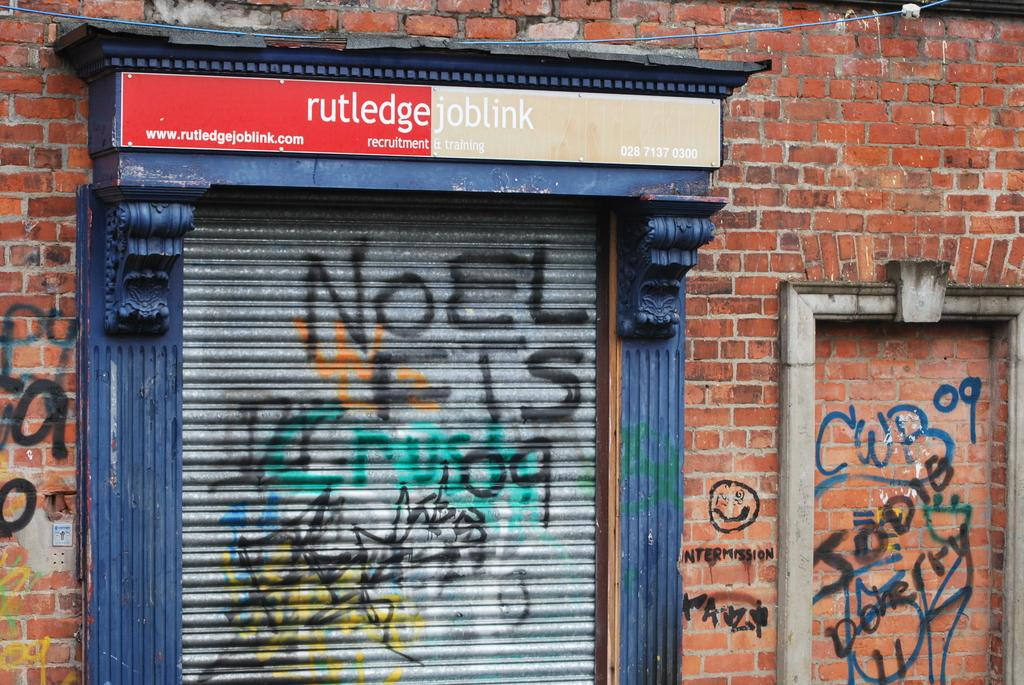What is the main object in the image? There is a board in the image. What can be seen on the shutter in the image? There are scribblings on the shutter in the image. What else in the image has scribblings on it? There are scribblings on the wall in the image. Where is the throne located in the image? There is no throne present in the image. What type of metal is the zinc used for in the image? There is no mention of zinc or any metal in the image. 